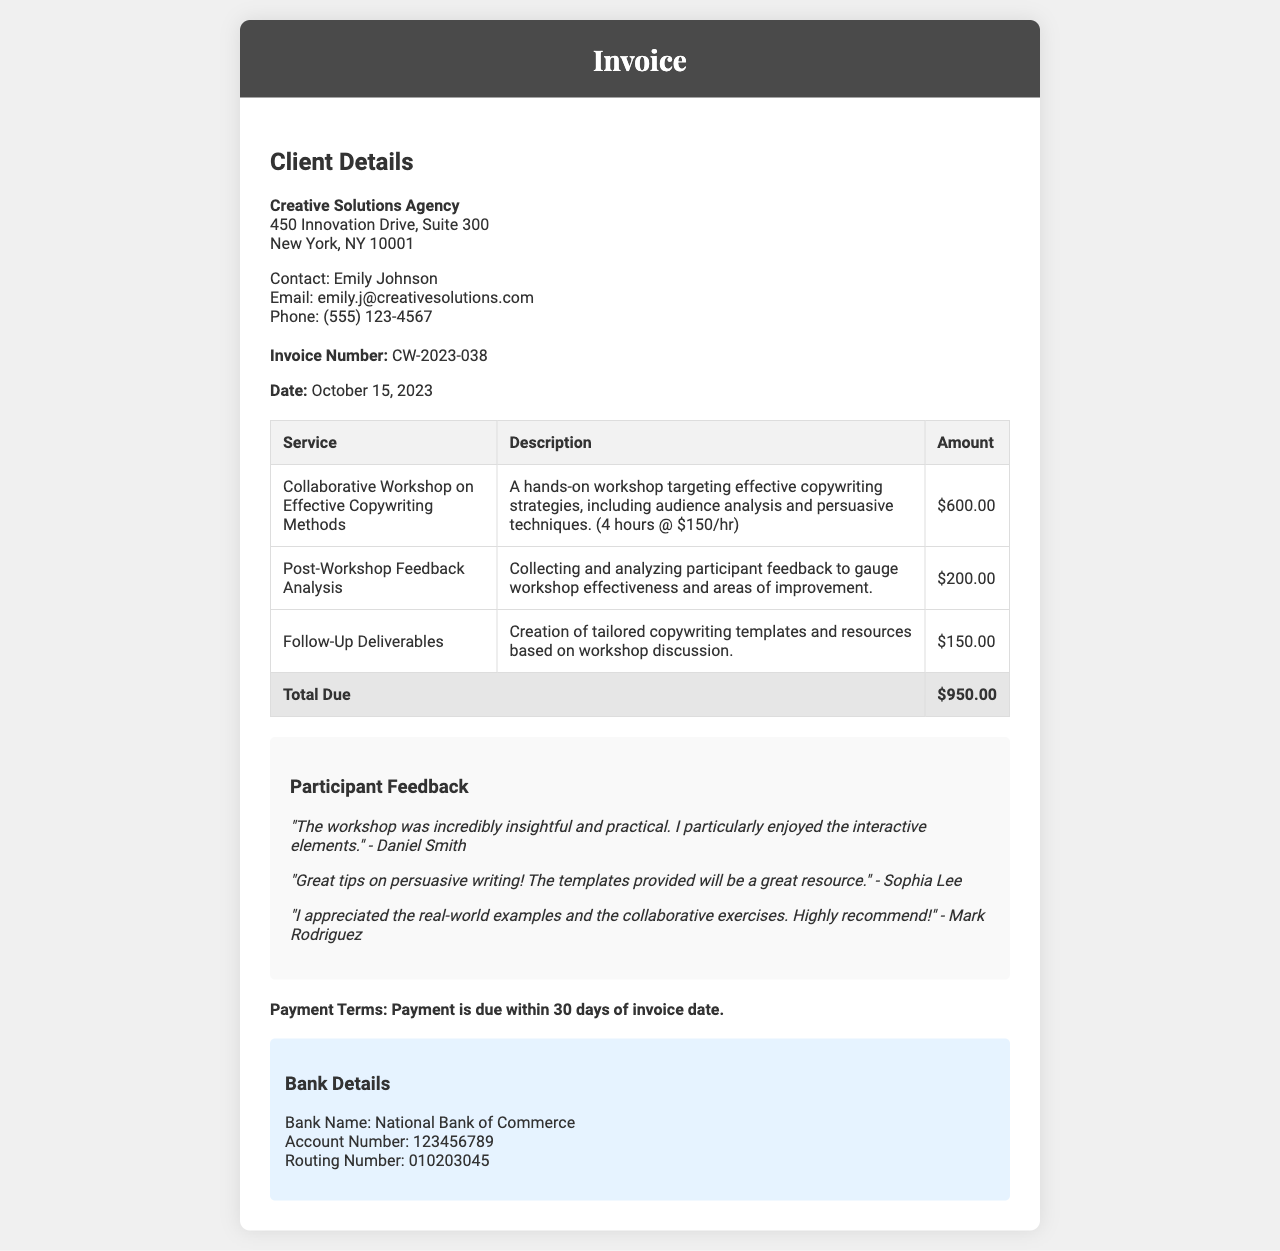What is the invoice number? The invoice number is a unique identifier for this transaction, which can be found in the document.
Answer: CW-2023-038 What is the date of the invoice? The date of the invoice indicates when it was issued, as seen in the document's details.
Answer: October 15, 2023 How much is charged for the Collaborative Workshop? This amount is specified in the table for the services rendered during the workshop in the document.
Answer: $600.00 Who is the contact person for the client? The contact person is essential information for communication and is provided in the client details section of the document.
Answer: Emily Johnson What is the total amount due? The total amount due is calculated from the services listed in the invoice table.
Answer: $950.00 What type of feedback did Daniel Smith provide? Feedback from participants adds value in this document, and Daniel Smith's comment is captured in the feedback section.
Answer: "The workshop was incredibly insightful and practical." What is the payment terms? This information defines when the payment should be made, which is outlined at the end of the document.
Answer: Payment is due within 30 days of invoice date What bank is listed for payment? The bank details provide essential information for processing the payment as shown in the document.
Answer: National Bank of Commerce What deliverable is associated with a $150 charge? This deliverable is specified in the table and entails the creation of resources after the workshop.
Answer: Follow-Up Deliverables 